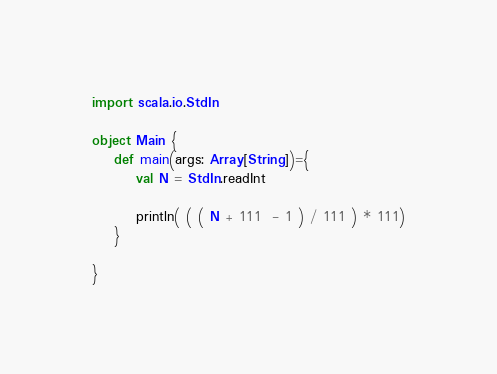Convert code to text. <code><loc_0><loc_0><loc_500><loc_500><_Scala_>import scala.io.StdIn

object Main {
	def main(args: Array[String])={
		val N = StdIn.readInt

		println( ( ( N + 111  - 1 ) / 111 ) * 111)
	}

}</code> 